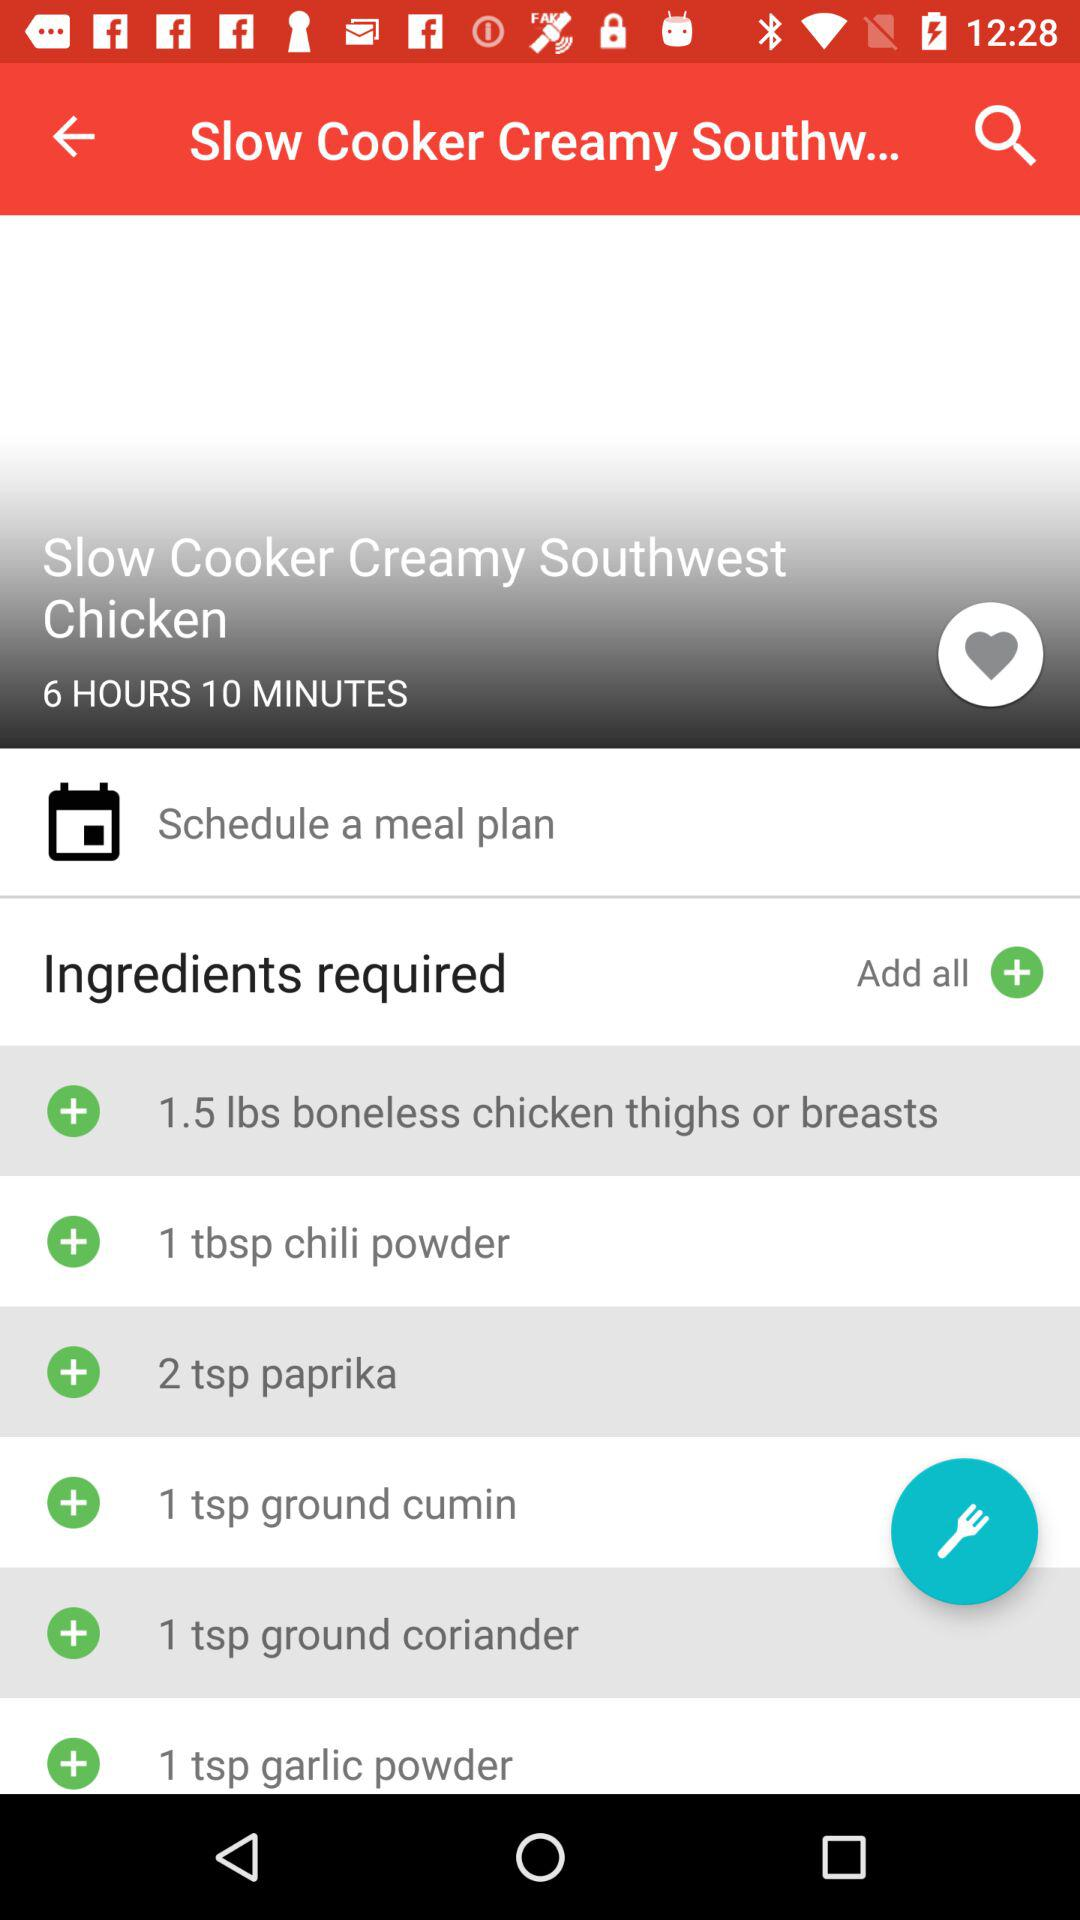How much garlic powder is required? There is a requirement of 1 teaspoon garlic powder. 